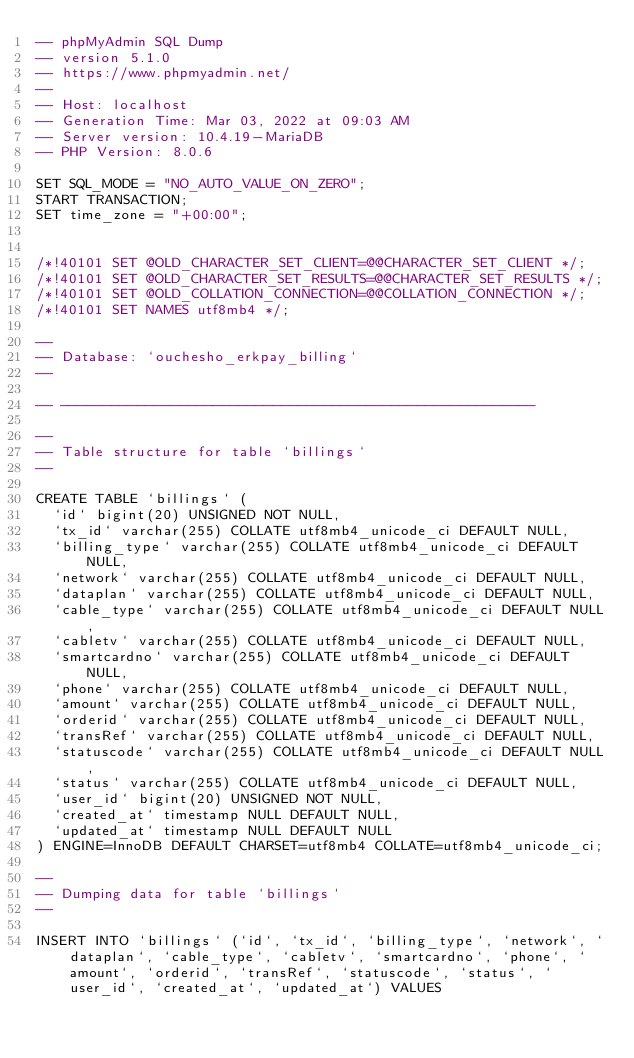<code> <loc_0><loc_0><loc_500><loc_500><_SQL_>-- phpMyAdmin SQL Dump
-- version 5.1.0
-- https://www.phpmyadmin.net/
--
-- Host: localhost
-- Generation Time: Mar 03, 2022 at 09:03 AM
-- Server version: 10.4.19-MariaDB
-- PHP Version: 8.0.6

SET SQL_MODE = "NO_AUTO_VALUE_ON_ZERO";
START TRANSACTION;
SET time_zone = "+00:00";


/*!40101 SET @OLD_CHARACTER_SET_CLIENT=@@CHARACTER_SET_CLIENT */;
/*!40101 SET @OLD_CHARACTER_SET_RESULTS=@@CHARACTER_SET_RESULTS */;
/*!40101 SET @OLD_COLLATION_CONNECTION=@@COLLATION_CONNECTION */;
/*!40101 SET NAMES utf8mb4 */;

--
-- Database: `ouchesho_erkpay_billing`
--

-- --------------------------------------------------------

--
-- Table structure for table `billings`
--

CREATE TABLE `billings` (
  `id` bigint(20) UNSIGNED NOT NULL,
  `tx_id` varchar(255) COLLATE utf8mb4_unicode_ci DEFAULT NULL,
  `billing_type` varchar(255) COLLATE utf8mb4_unicode_ci DEFAULT NULL,
  `network` varchar(255) COLLATE utf8mb4_unicode_ci DEFAULT NULL,
  `dataplan` varchar(255) COLLATE utf8mb4_unicode_ci DEFAULT NULL,
  `cable_type` varchar(255) COLLATE utf8mb4_unicode_ci DEFAULT NULL,
  `cabletv` varchar(255) COLLATE utf8mb4_unicode_ci DEFAULT NULL,
  `smartcardno` varchar(255) COLLATE utf8mb4_unicode_ci DEFAULT NULL,
  `phone` varchar(255) COLLATE utf8mb4_unicode_ci DEFAULT NULL,
  `amount` varchar(255) COLLATE utf8mb4_unicode_ci DEFAULT NULL,
  `orderid` varchar(255) COLLATE utf8mb4_unicode_ci DEFAULT NULL,
  `transRef` varchar(255) COLLATE utf8mb4_unicode_ci DEFAULT NULL,
  `statuscode` varchar(255) COLLATE utf8mb4_unicode_ci DEFAULT NULL,
  `status` varchar(255) COLLATE utf8mb4_unicode_ci DEFAULT NULL,
  `user_id` bigint(20) UNSIGNED NOT NULL,
  `created_at` timestamp NULL DEFAULT NULL,
  `updated_at` timestamp NULL DEFAULT NULL
) ENGINE=InnoDB DEFAULT CHARSET=utf8mb4 COLLATE=utf8mb4_unicode_ci;

--
-- Dumping data for table `billings`
--

INSERT INTO `billings` (`id`, `tx_id`, `billing_type`, `network`, `dataplan`, `cable_type`, `cabletv`, `smartcardno`, `phone`, `amount`, `orderid`, `transRef`, `statuscode`, `status`, `user_id`, `created_at`, `updated_at`) VALUES</code> 